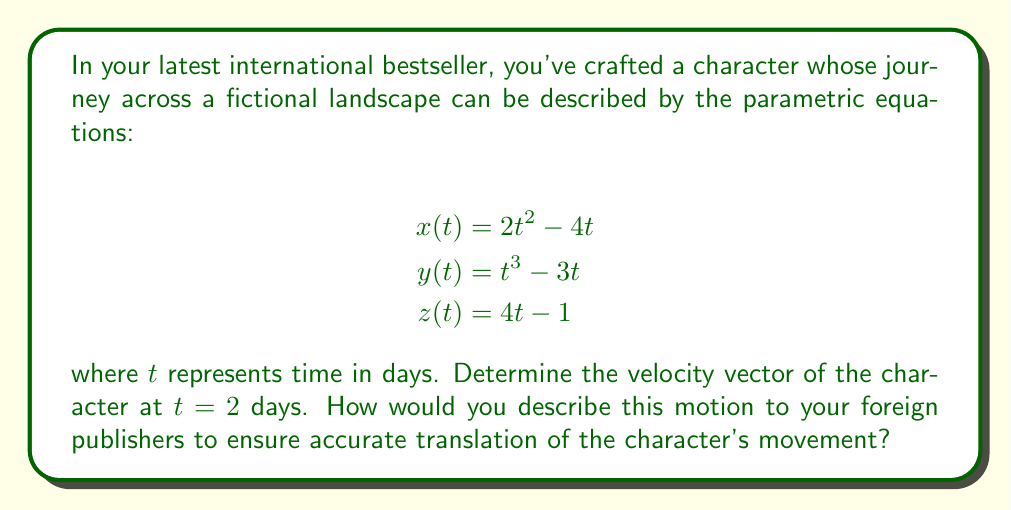Show me your answer to this math problem. To find the velocity vector at $t = 2$ days, we need to differentiate each component of the position vector with respect to $t$:

1) First, let's find the velocity components:

   $$v_x(t) = \frac{dx}{dt} = 4t - 4$$
   $$v_y(t) = \frac{dy}{dt} = 3t^2 - 3$$
   $$v_z(t) = \frac{dz}{dt} = 4$$

2) Now, we evaluate each component at $t = 2$:

   $$v_x(2) = 4(2) - 4 = 4$$
   $$v_y(2) = 3(2)^2 - 3 = 9$$
   $$v_z(2) = 4$$

3) The velocity vector at $t = 2$ is therefore:

   $$\vec{v}(2) = \langle 4, 9, 4 \rangle$$

To describe this motion to foreign publishers:

The character is moving in a three-dimensional space. At the 2-day mark, they are traveling:
- 4 units per day in the x-direction (eastward, for example)
- 9 units per day in the y-direction (northward, for example)
- 4 units per day in the z-direction (upward, for example)

This indicates that the character is moving more quickly in the y-direction compared to the x and z directions, which have equal rates of change at this point in time.
Answer: The velocity vector at $t = 2$ days is $\vec{v}(2) = \langle 4, 9, 4 \rangle$. 